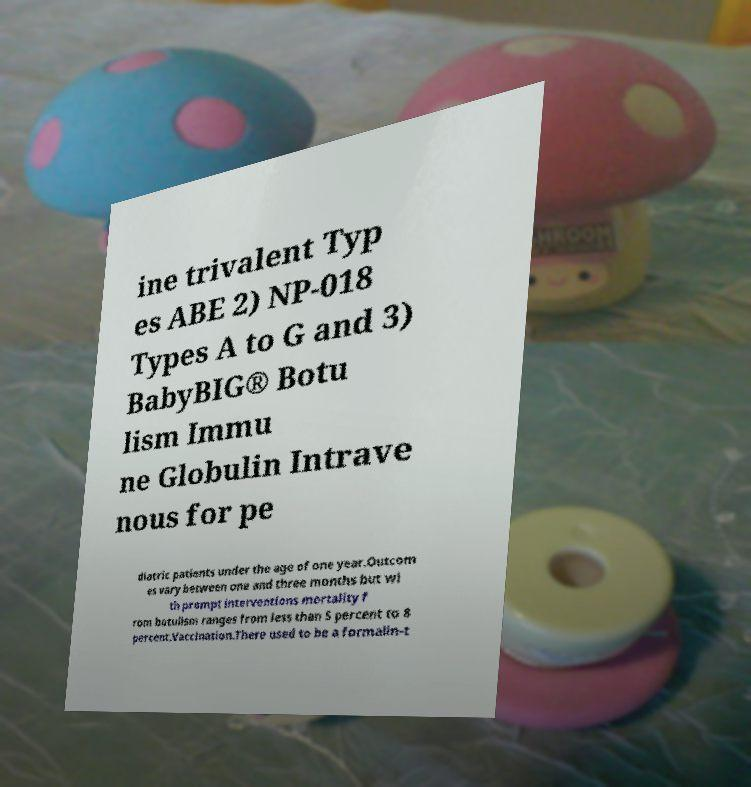Could you extract and type out the text from this image? ine trivalent Typ es ABE 2) NP-018 Types A to G and 3) BabyBIG® Botu lism Immu ne Globulin Intrave nous for pe diatric patients under the age of one year.Outcom es vary between one and three months but wi th prompt interventions mortality f rom botulism ranges from less than 5 percent to 8 percent.Vaccination.There used to be a formalin-t 